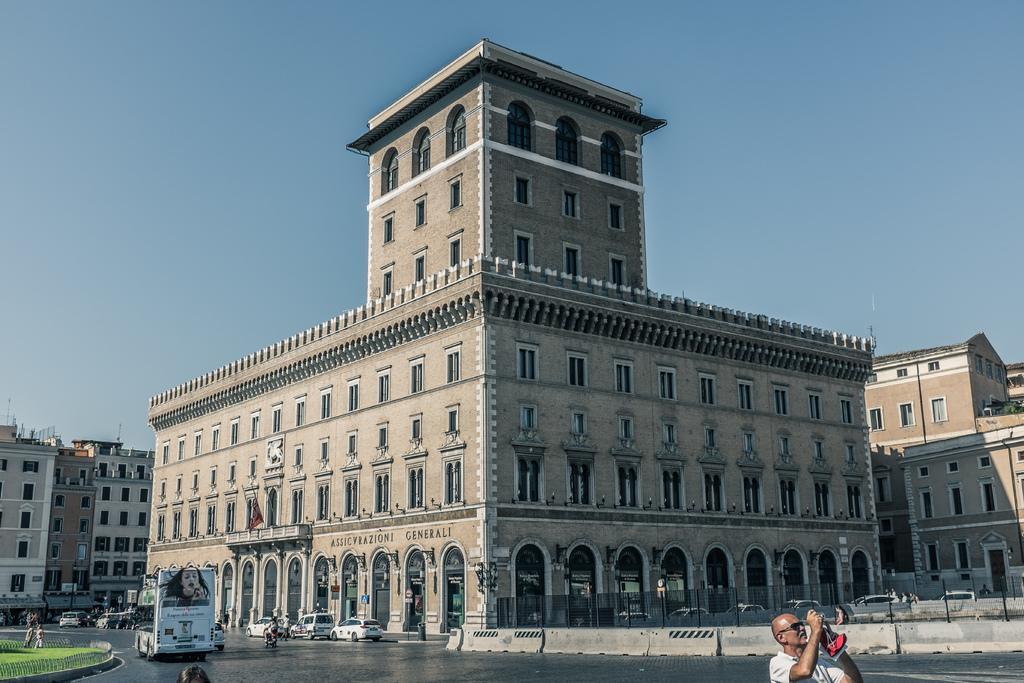Describe this image in one or two sentences. In this picture we can see buildings, cars, bike and at the left side of the image there is a grass on the surface. At front there is a person standing by holding the camera and at the background of the image there is sky. 